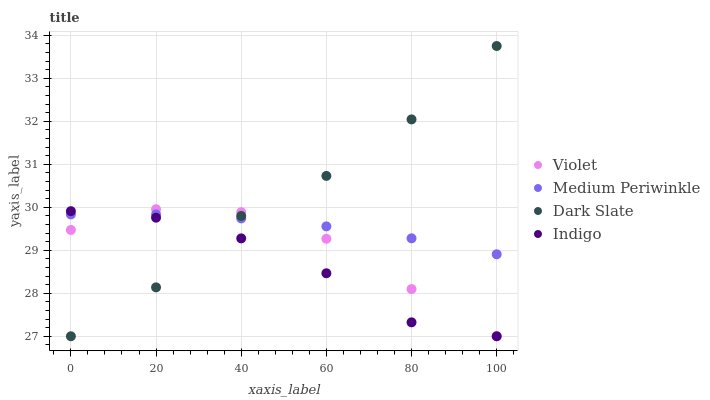Does Indigo have the minimum area under the curve?
Answer yes or no. Yes. Does Dark Slate have the maximum area under the curve?
Answer yes or no. Yes. Does Medium Periwinkle have the minimum area under the curve?
Answer yes or no. No. Does Medium Periwinkle have the maximum area under the curve?
Answer yes or no. No. Is Medium Periwinkle the smoothest?
Answer yes or no. Yes. Is Dark Slate the roughest?
Answer yes or no. Yes. Is Indigo the smoothest?
Answer yes or no. No. Is Indigo the roughest?
Answer yes or no. No. Does Dark Slate have the lowest value?
Answer yes or no. Yes. Does Medium Periwinkle have the lowest value?
Answer yes or no. No. Does Dark Slate have the highest value?
Answer yes or no. Yes. Does Indigo have the highest value?
Answer yes or no. No. Does Violet intersect Medium Periwinkle?
Answer yes or no. Yes. Is Violet less than Medium Periwinkle?
Answer yes or no. No. Is Violet greater than Medium Periwinkle?
Answer yes or no. No. 